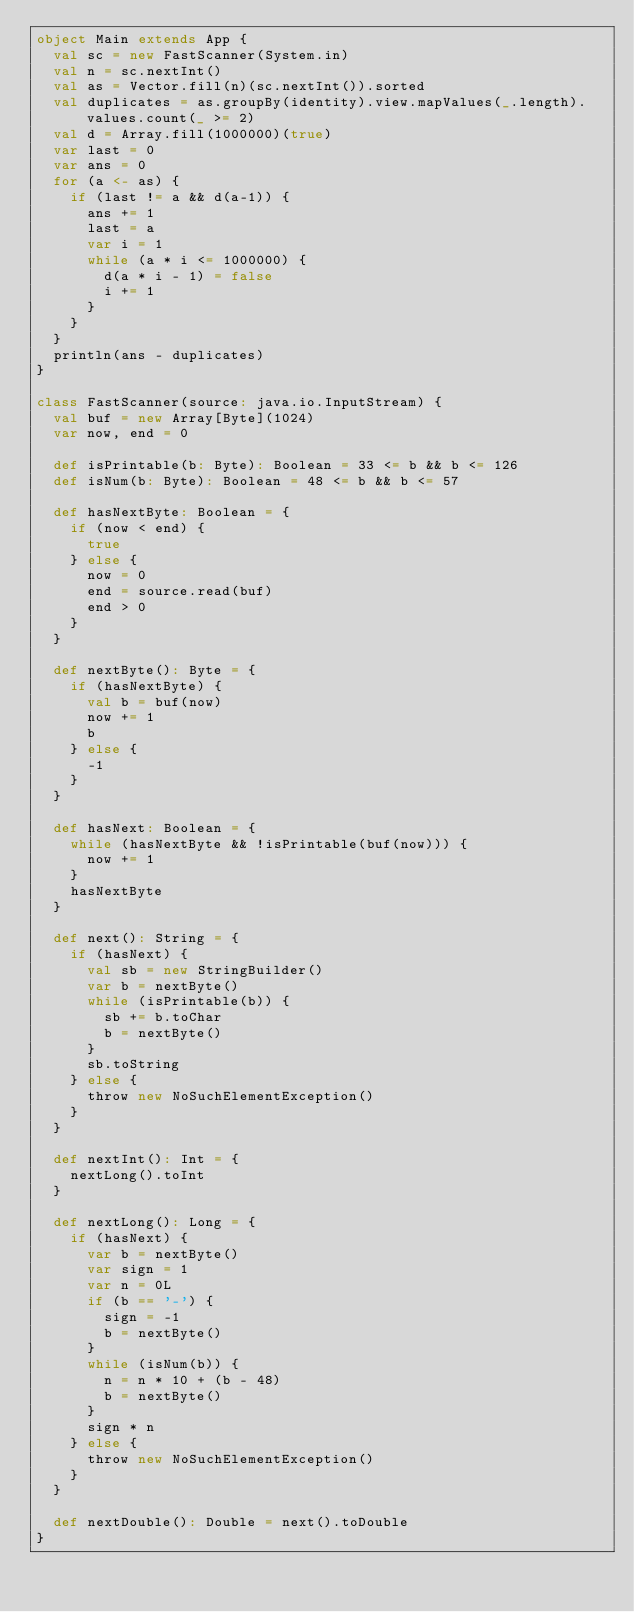Convert code to text. <code><loc_0><loc_0><loc_500><loc_500><_Scala_>object Main extends App {
  val sc = new FastScanner(System.in)
  val n = sc.nextInt()
  val as = Vector.fill(n)(sc.nextInt()).sorted
  val duplicates = as.groupBy(identity).view.mapValues(_.length).values.count(_ >= 2)
  val d = Array.fill(1000000)(true)
  var last = 0
  var ans = 0
  for (a <- as) {
    if (last != a && d(a-1)) {
      ans += 1
      last = a
      var i = 1
      while (a * i <= 1000000) {
        d(a * i - 1) = false
        i += 1
      }
    }
  }
  println(ans - duplicates)
}

class FastScanner(source: java.io.InputStream) {
  val buf = new Array[Byte](1024)
  var now, end = 0

  def isPrintable(b: Byte): Boolean = 33 <= b && b <= 126
  def isNum(b: Byte): Boolean = 48 <= b && b <= 57

  def hasNextByte: Boolean = {
    if (now < end) {
      true
    } else {
      now = 0
      end = source.read(buf)
      end > 0
    }
  }

  def nextByte(): Byte = {
    if (hasNextByte) {
      val b = buf(now)
      now += 1
      b
    } else {
      -1
    }
  }

  def hasNext: Boolean = {
    while (hasNextByte && !isPrintable(buf(now))) {
      now += 1
    }
    hasNextByte
  }

  def next(): String = {
    if (hasNext) {
      val sb = new StringBuilder()
      var b = nextByte()
      while (isPrintable(b)) {
        sb += b.toChar
        b = nextByte()
      }
      sb.toString
    } else {
      throw new NoSuchElementException()
    }
  }

  def nextInt(): Int = {
    nextLong().toInt
  }

  def nextLong(): Long = {
    if (hasNext) {
      var b = nextByte()
      var sign = 1
      var n = 0L
      if (b == '-') {
        sign = -1
        b = nextByte()
      }
      while (isNum(b)) {
        n = n * 10 + (b - 48)
        b = nextByte()
      }
      sign * n
    } else {
      throw new NoSuchElementException()
    }
  }

  def nextDouble(): Double = next().toDouble
}
</code> 